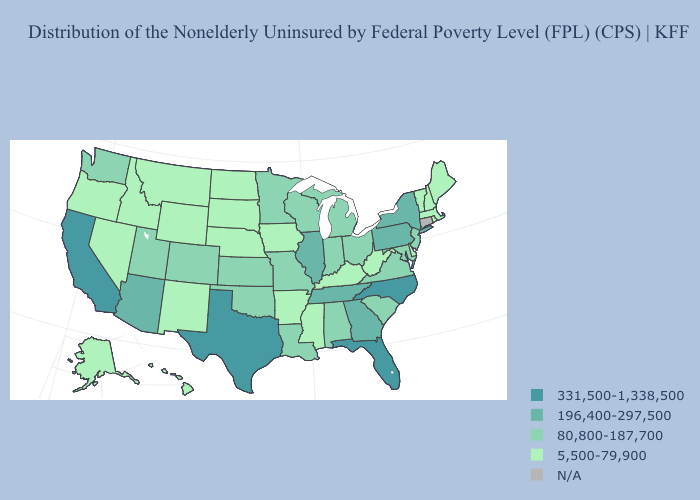Does the first symbol in the legend represent the smallest category?
Short answer required. No. Which states have the lowest value in the South?
Write a very short answer. Arkansas, Delaware, Kentucky, Mississippi, West Virginia. Among the states that border Colorado , does Oklahoma have the highest value?
Give a very brief answer. No. What is the value of Georgia?
Keep it brief. 196,400-297,500. Does Pennsylvania have the highest value in the Northeast?
Keep it brief. Yes. Which states have the lowest value in the USA?
Give a very brief answer. Alaska, Arkansas, Delaware, Hawaii, Idaho, Iowa, Kentucky, Maine, Massachusetts, Mississippi, Montana, Nebraska, Nevada, New Hampshire, New Mexico, North Dakota, Oregon, Rhode Island, South Dakota, Vermont, West Virginia, Wyoming. What is the value of Minnesota?
Be succinct. 80,800-187,700. What is the value of Oklahoma?
Short answer required. 80,800-187,700. Does Alabama have the lowest value in the USA?
Be succinct. No. Does New York have the highest value in the USA?
Quick response, please. No. Does the map have missing data?
Give a very brief answer. Yes. Does West Virginia have the lowest value in the USA?
Short answer required. Yes. What is the highest value in the West ?
Be succinct. 331,500-1,338,500. 